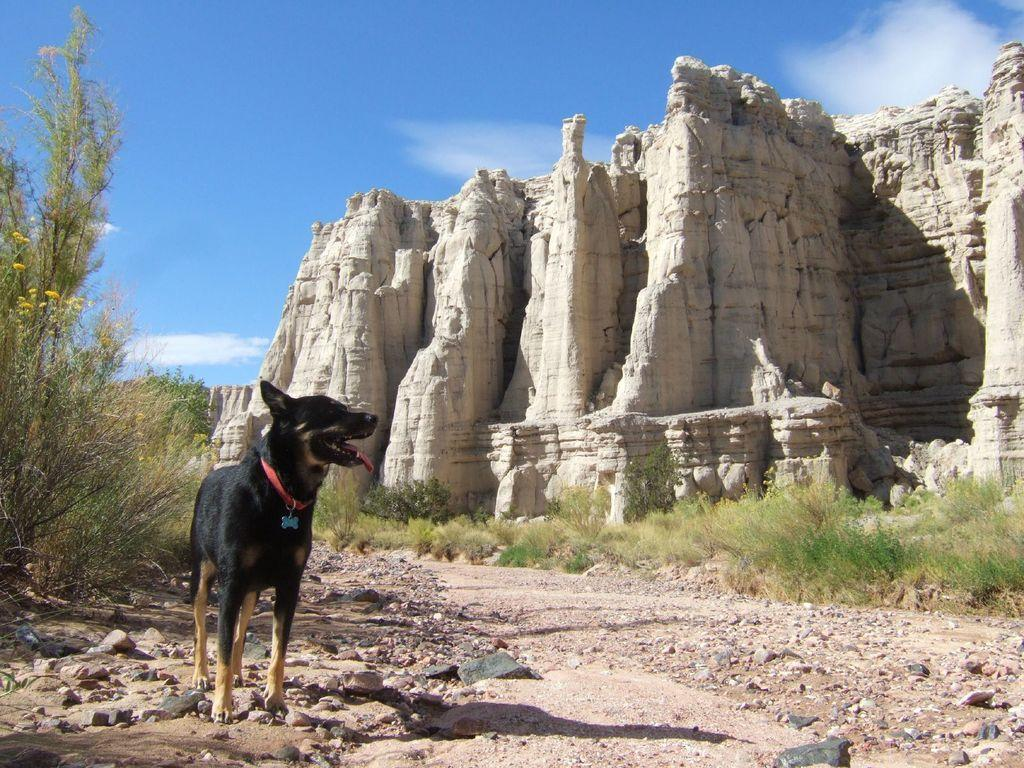What is located on the left side of the image? There are trees, stones, and a dog on the left side of the image. What can be seen in the background of the image? There is a hill, sky, and clouds visible in the background of the image. Can you tell me how many zebras are visible on the hill in the image? There are no zebras visible in the image; only trees, stones, a dog, a hill, sky, and clouds are present. What type of machine can be seen operating on the hill in the image? There is no machine present in the image; only natural elements and a dog are visible. 